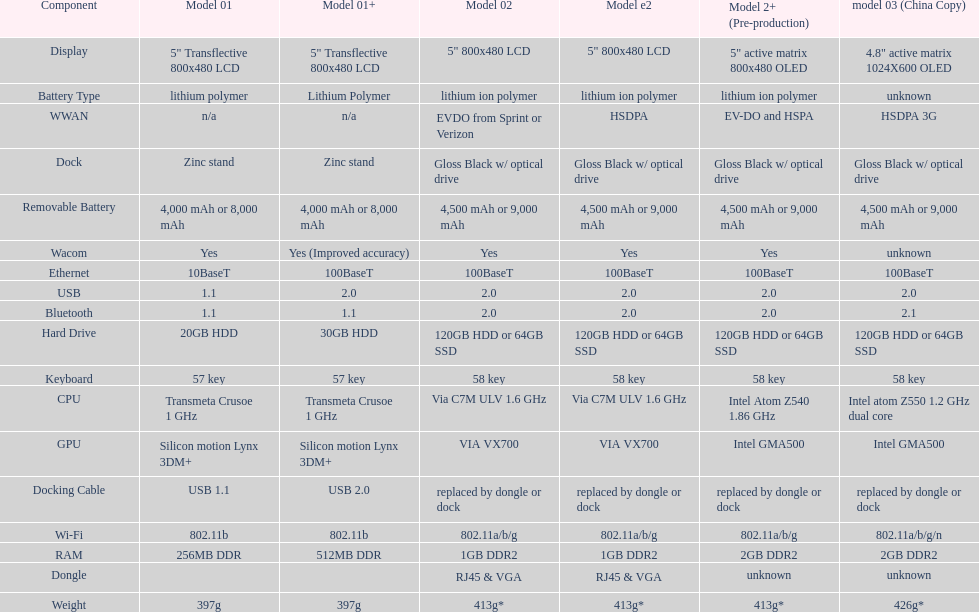6ghz processing speed? 2. 